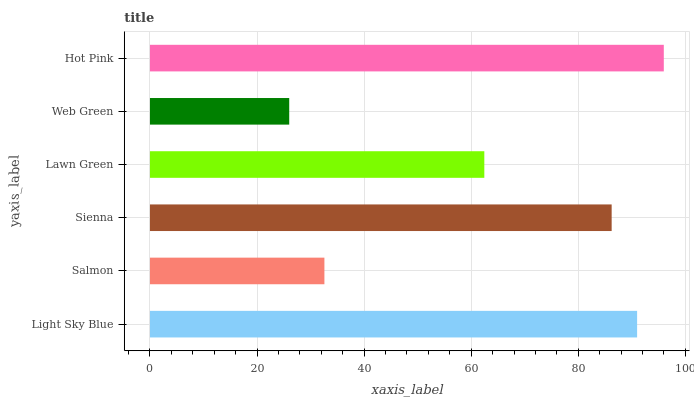Is Web Green the minimum?
Answer yes or no. Yes. Is Hot Pink the maximum?
Answer yes or no. Yes. Is Salmon the minimum?
Answer yes or no. No. Is Salmon the maximum?
Answer yes or no. No. Is Light Sky Blue greater than Salmon?
Answer yes or no. Yes. Is Salmon less than Light Sky Blue?
Answer yes or no. Yes. Is Salmon greater than Light Sky Blue?
Answer yes or no. No. Is Light Sky Blue less than Salmon?
Answer yes or no. No. Is Sienna the high median?
Answer yes or no. Yes. Is Lawn Green the low median?
Answer yes or no. Yes. Is Salmon the high median?
Answer yes or no. No. Is Hot Pink the low median?
Answer yes or no. No. 